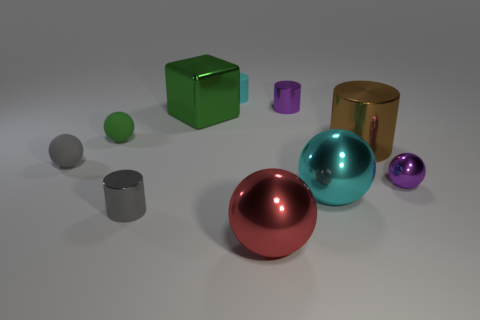There is a green object that is the same material as the big cyan ball; what is its size?
Make the answer very short. Large. Is the size of the matte ball on the left side of the green matte sphere the same as the cyan shiny object in front of the metal cube?
Your answer should be very brief. No. Is the material of the green sphere the same as the cyan thing that is in front of the small purple cylinder?
Your response must be concise. No. The rubber sphere that is the same size as the gray matte object is what color?
Give a very brief answer. Green. What is the size of the cyan thing on the right side of the tiny purple metal object that is behind the big green thing?
Provide a succinct answer. Large. There is a block; is its color the same as the small rubber sphere that is behind the gray rubber object?
Your answer should be very brief. Yes. Is the number of gray things that are on the right side of the tiny metallic ball less than the number of small red matte cylinders?
Ensure brevity in your answer.  No. How many other objects are there of the same size as the green sphere?
Offer a very short reply. 5. There is a tiny purple metallic object to the left of the brown metal object; is its shape the same as the cyan matte thing?
Provide a succinct answer. Yes. Are there more large green shiny things that are in front of the metallic block than large gray blocks?
Your answer should be very brief. No. 